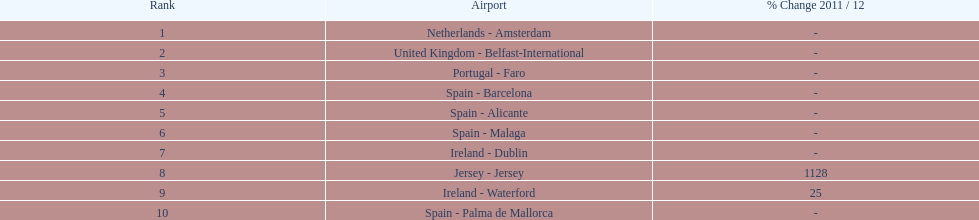How many passengers are going to or coming from spain? 217,548. Would you mind parsing the complete table? {'header': ['Rank', 'Airport', '% Change 2011 / 12'], 'rows': [['1', 'Netherlands - Amsterdam', '-'], ['2', 'United Kingdom - Belfast-International', '-'], ['3', 'Portugal - Faro', '-'], ['4', 'Spain - Barcelona', '-'], ['5', 'Spain - Alicante', '-'], ['6', 'Spain - Malaga', '-'], ['7', 'Ireland - Dublin', '-'], ['8', 'Jersey - Jersey', '1128'], ['9', 'Ireland - Waterford', '25'], ['10', 'Spain - Palma de Mallorca', '-']]} 